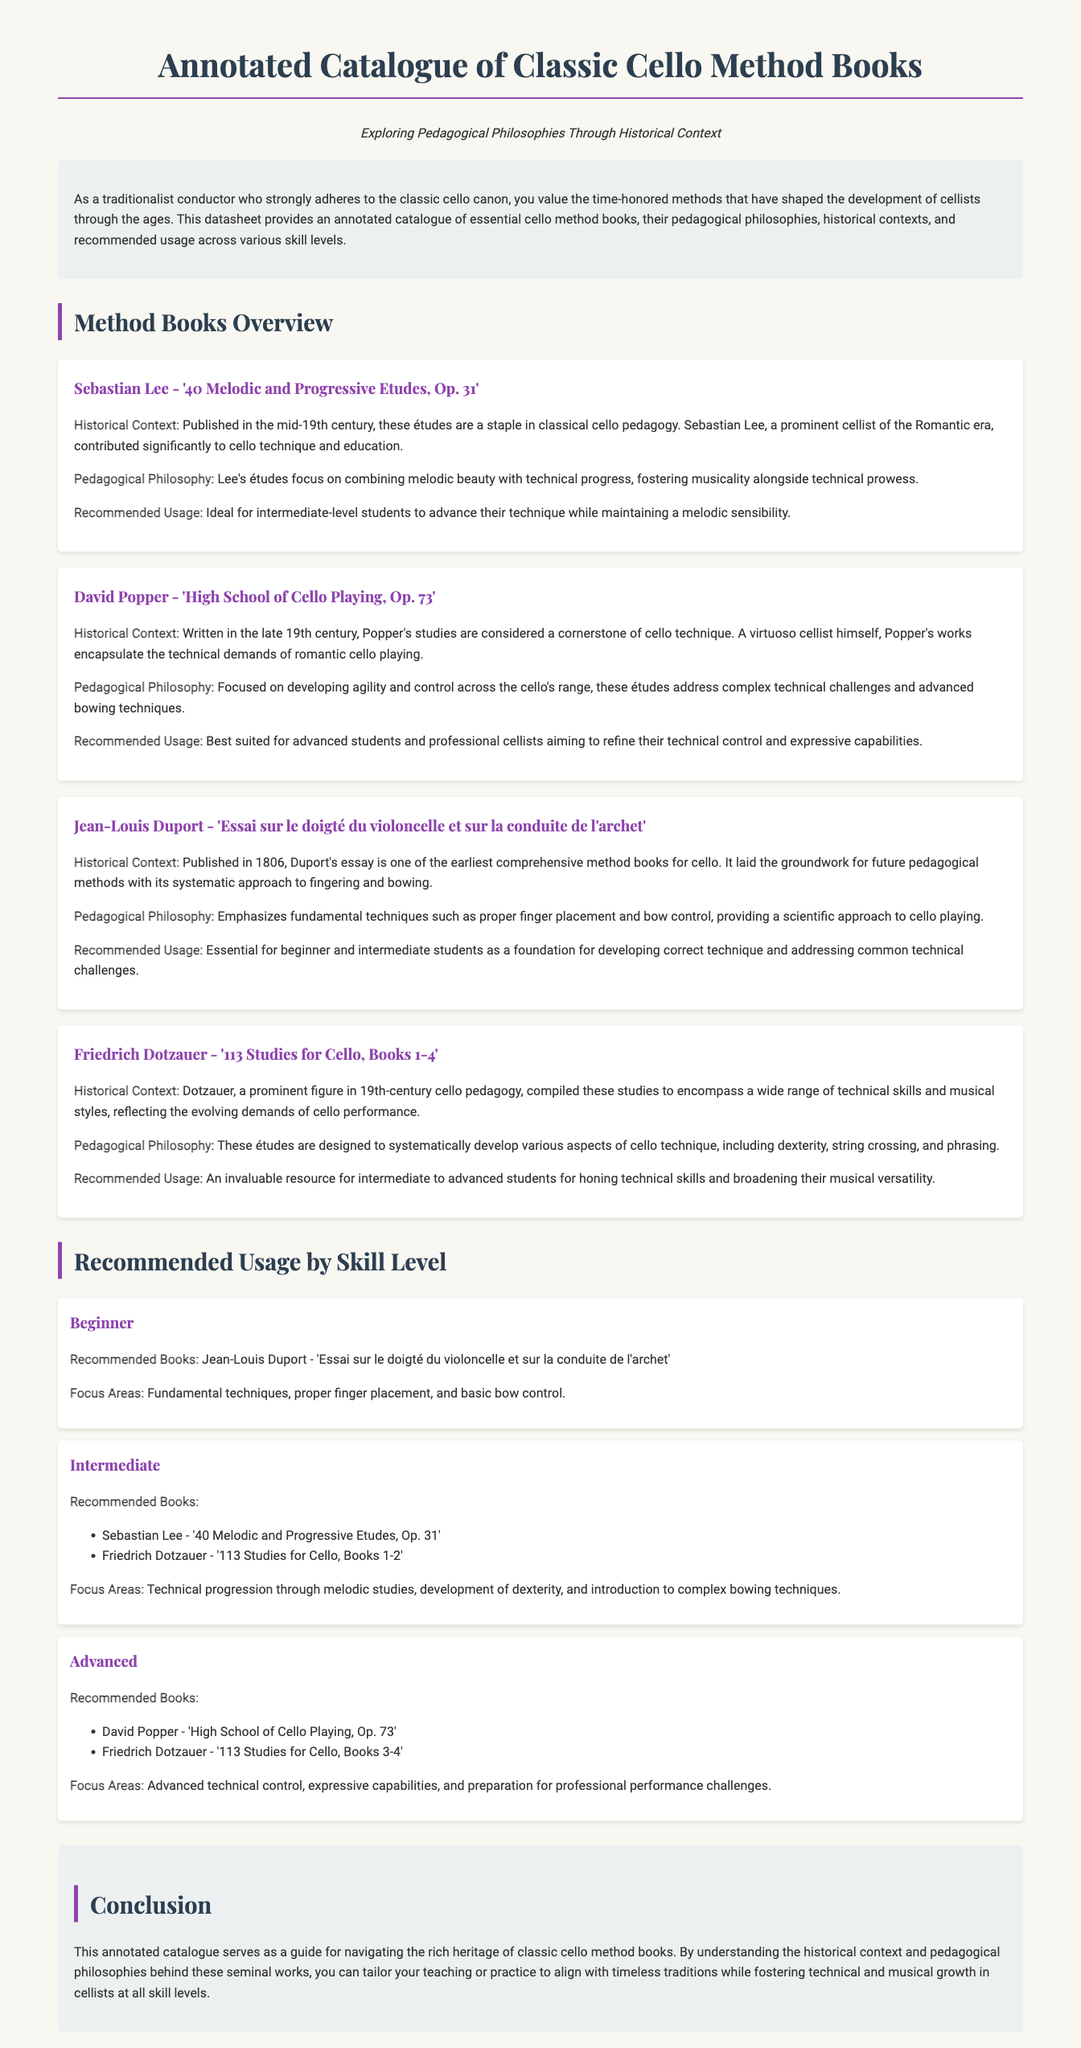What is the title of the catalogue? The title of the catalogue is explicitly stated at the top of the document.
Answer: Annotated Catalogue of Classic Cello Method Books Who authored '40 Melodic and Progressive Etudes, Op. 31'? The author of this specific work is mentioned in conjunction with the title within the method book section.
Answer: Sebastian Lee Which skill level is 'High School of Cello Playing, Op. 73' suited for? The recommended usage context for each method book specifies the associated skill level.
Answer: Advanced What year was 'Essai sur le doigté du violoncelle et sur la conduite de l'archet' published? The historical context section provides the publication year directly after the title information.
Answer: 1806 What is the primary focus area for beginner-level students? The focus areas for each skill level are listed under the respective recommendations for beginner students.
Answer: Fundamental techniques Which two composers' works are recommended for intermediate students? This question requires gathering information about the specific recommendations listed for intermediate skill levels.
Answer: Sebastian Lee, Friedrich Dotzauer What pedagogical philosophy is associated with David Popper's works? The pedagogical philosophies are summarized for each method book, providing insight into their teachings.
Answer: Developing agility and control How many études are in Dotzauer's '113 Studies for Cello'? The title of the method book includes the total number of études, directly answering the question.
Answer: 113 What color is used for the headings in the method book section? The stylesheet indicates the color styling attributed to different headings within the document.
Answer: #8e44ad 